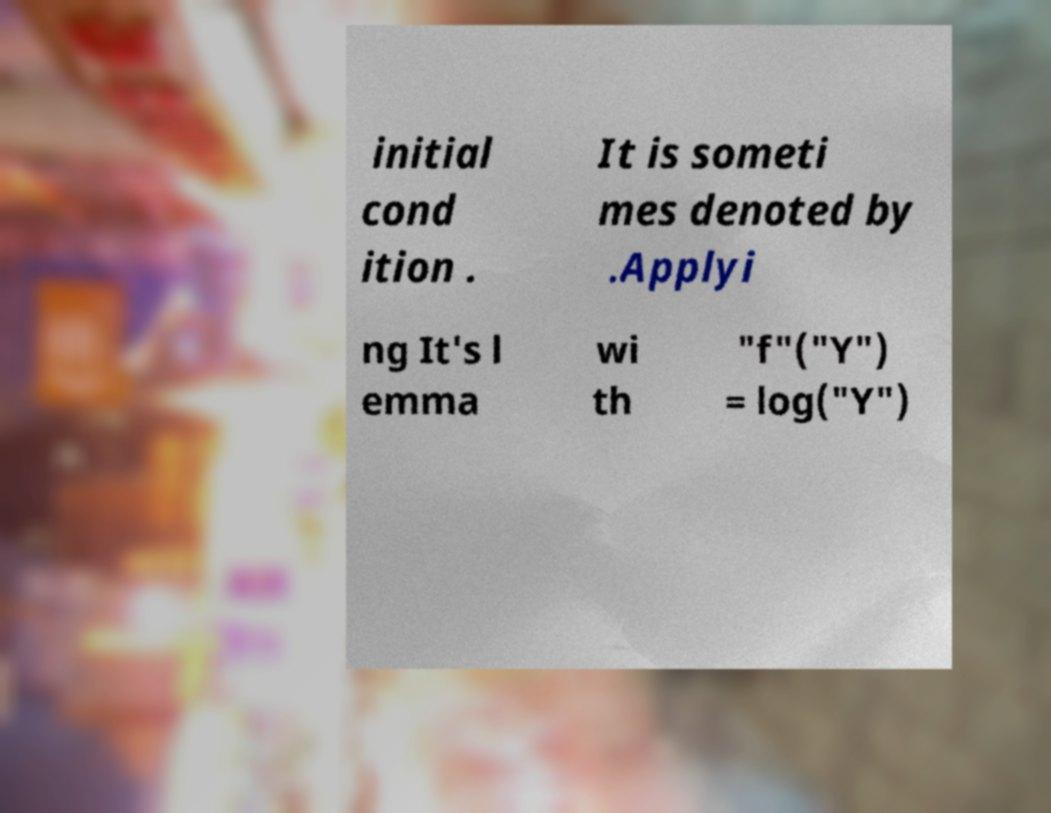I need the written content from this picture converted into text. Can you do that? initial cond ition . It is someti mes denoted by .Applyi ng It's l emma wi th "f"("Y") = log("Y") 